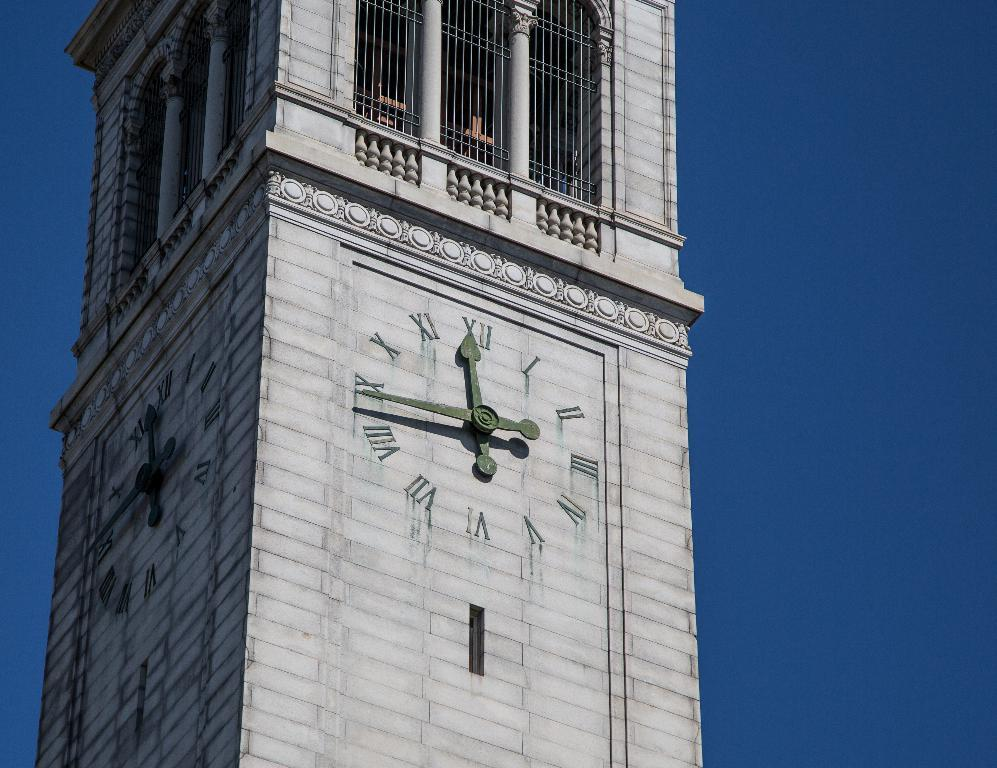What is the main structure in the image? There is a tower in the image. What type of barrier can be seen in the image? There is a fence in the image. What time-telling device is present in the image? There is a clock in the image. What color is the sky in the image? The sky is blue in the image. What flavor of ice cream is the baby eating in the image? There is no baby or ice cream present in the image. Does the rain affect the visibility of the tower in the image? There is no rain present in the image, so it does not affect the visibility of the tower. 